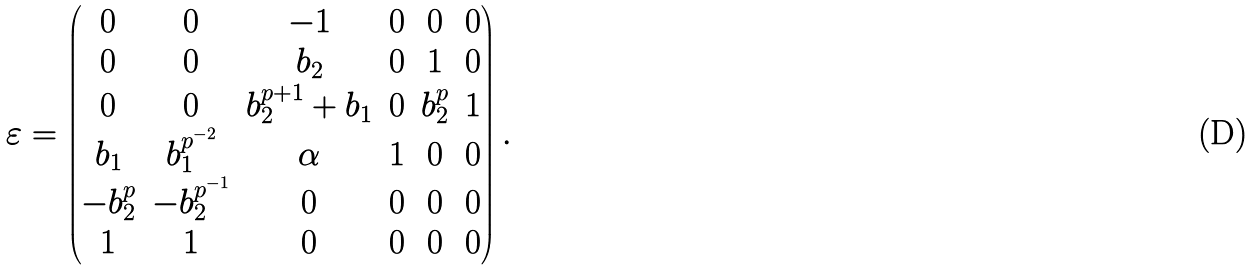<formula> <loc_0><loc_0><loc_500><loc_500>\varepsilon = \begin{pmatrix} 0 & 0 & - 1 & 0 & 0 & 0 \\ 0 & 0 & b _ { 2 } & 0 & 1 & 0 \\ 0 & 0 & b _ { 2 } ^ { p + 1 } + b _ { 1 } & 0 & b _ { 2 } ^ { p } & 1 \\ b _ { 1 } & b _ { 1 } ^ { p ^ { - 2 } } & \alpha & 1 & 0 & 0 \\ - b _ { 2 } ^ { p } & - b _ { 2 } ^ { p ^ { - 1 } } & 0 & 0 & 0 & 0 \\ 1 & 1 & 0 & 0 & 0 & 0 \end{pmatrix} .</formula> 